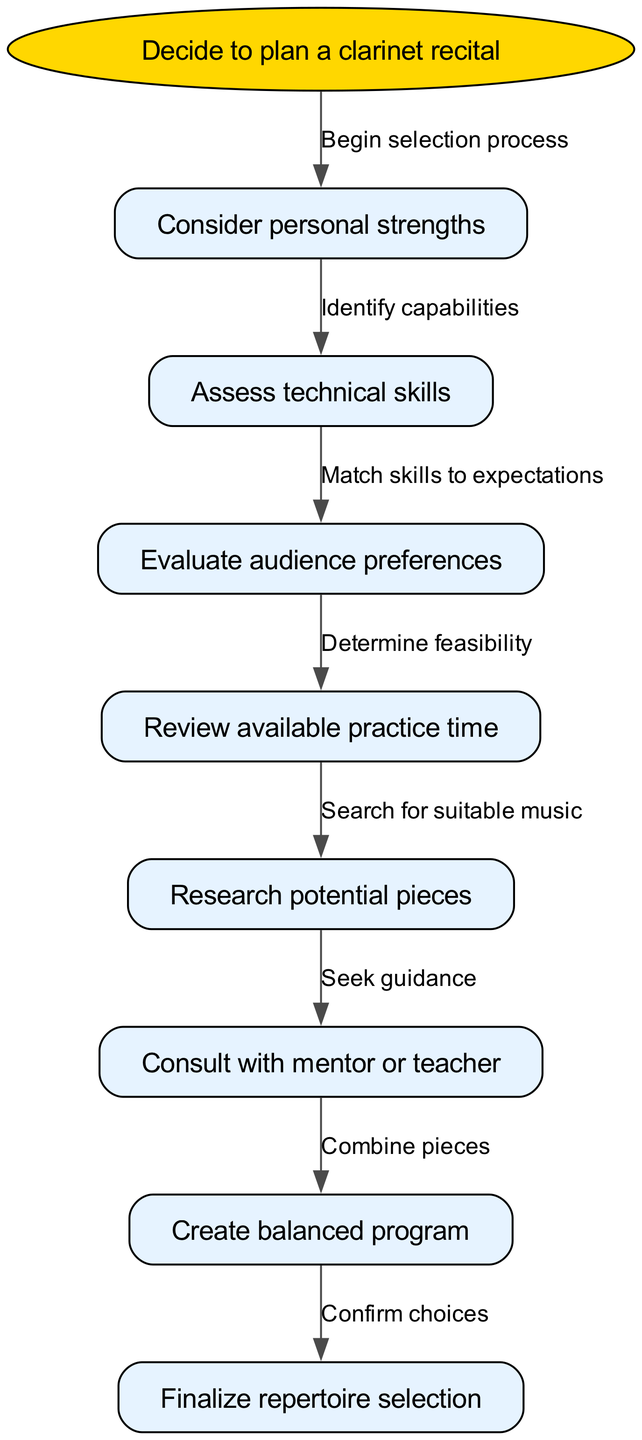What is the starting point of the diagram? The starting point of the diagram, which is marked as the first node, is "Decide to plan a clarinet recital." This node establishes the purpose of the flow chart.
Answer: Decide to plan a clarinet recital How many nodes are present in the diagram? The diagram includes a total of 8 nodes, which represent different stages in the decision-making process for selecting repertoire.
Answer: 8 What node follows "Research potential pieces"? The node that follows "Research potential pieces" is "Consult with mentor or teacher." This indicates the next step in the process after researching potential pieces.
Answer: Consult with mentor or teacher What is the relationship between "Evaluate audience preferences" and "Review available practice time"? The relationship is that "Evaluate audience preferences" leads to "Review available practice time," as it is necessary to determine feasibility after evaluating what the audience might prefer.
Answer: Determine feasibility What is the last node in the decision-making process? The last node in the diagram is "Finalize repertoire selection," which indicates the conclusion of the process after all previous steps have been completed.
Answer: Finalize repertoire selection What is the transition between "Consider personal strengths" and "Assess technical skills"? The transition is labeled "Identify capabilities," which suggests that personal strengths are used to determine the technical skills that the clarinet player possesses.
Answer: Identify capabilities List all the nodes that involve consulting or seeking advice. The nodes that involve consulting or seeking advice are "Consult with mentor or teacher." This is the only specific instance dedicated to seeking external guidance in the process.
Answer: Consult with mentor or teacher What happens after "Create balanced program"? After "Create balanced program," the next step is "Finalize repertoire selection," indicating that after creating a program, the next action is to confirm the pieces selected.
Answer: Finalize repertoire selection How does one determine if the repertoire is feasible? The process includes evaluating audience preferences before reviewing available practice time. This sequence ensures that both preferences and practice time are considered to determine feasibility.
Answer: Determine feasibility 